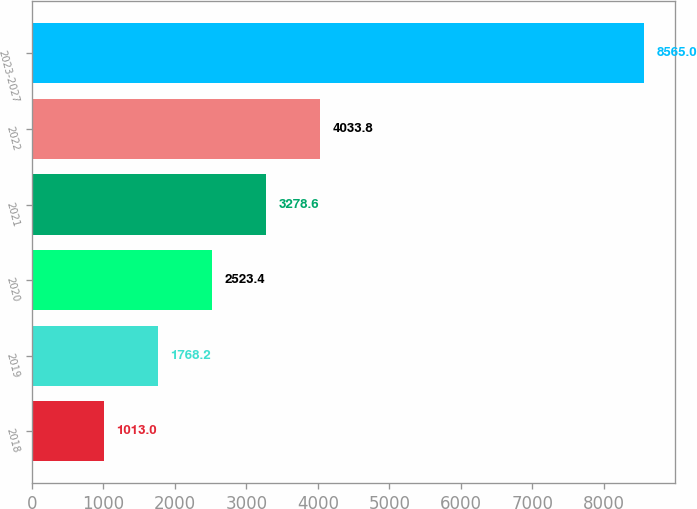Convert chart to OTSL. <chart><loc_0><loc_0><loc_500><loc_500><bar_chart><fcel>2018<fcel>2019<fcel>2020<fcel>2021<fcel>2022<fcel>2023-2027<nl><fcel>1013<fcel>1768.2<fcel>2523.4<fcel>3278.6<fcel>4033.8<fcel>8565<nl></chart> 